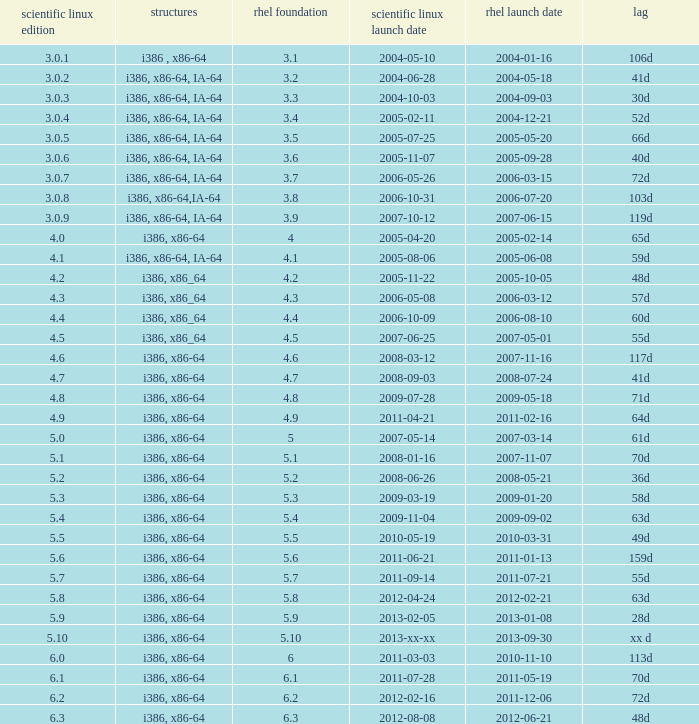Name the delay when scientific linux release is 5.10 Xx d. 